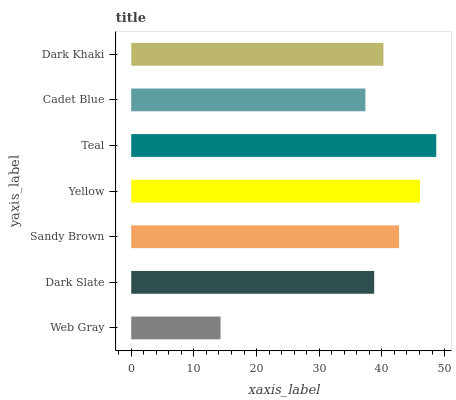Is Web Gray the minimum?
Answer yes or no. Yes. Is Teal the maximum?
Answer yes or no. Yes. Is Dark Slate the minimum?
Answer yes or no. No. Is Dark Slate the maximum?
Answer yes or no. No. Is Dark Slate greater than Web Gray?
Answer yes or no. Yes. Is Web Gray less than Dark Slate?
Answer yes or no. Yes. Is Web Gray greater than Dark Slate?
Answer yes or no. No. Is Dark Slate less than Web Gray?
Answer yes or no. No. Is Dark Khaki the high median?
Answer yes or no. Yes. Is Dark Khaki the low median?
Answer yes or no. Yes. Is Web Gray the high median?
Answer yes or no. No. Is Yellow the low median?
Answer yes or no. No. 